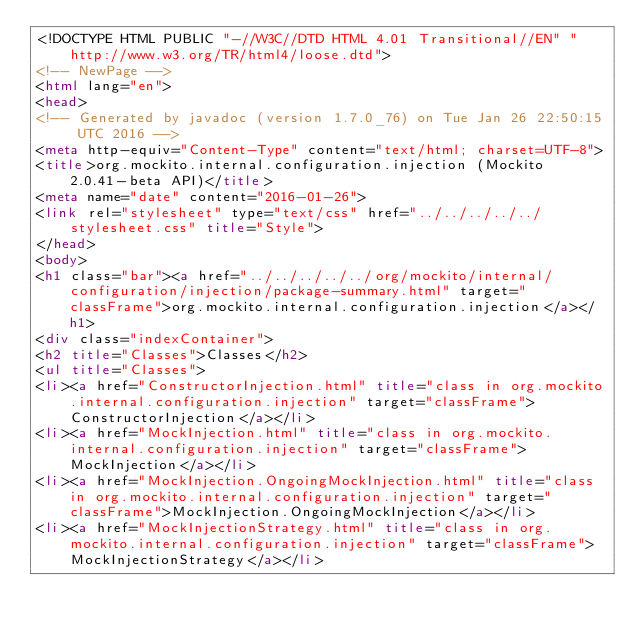<code> <loc_0><loc_0><loc_500><loc_500><_HTML_><!DOCTYPE HTML PUBLIC "-//W3C//DTD HTML 4.01 Transitional//EN" "http://www.w3.org/TR/html4/loose.dtd">
<!-- NewPage -->
<html lang="en">
<head>
<!-- Generated by javadoc (version 1.7.0_76) on Tue Jan 26 22:50:15 UTC 2016 -->
<meta http-equiv="Content-Type" content="text/html; charset=UTF-8">
<title>org.mockito.internal.configuration.injection (Mockito 2.0.41-beta API)</title>
<meta name="date" content="2016-01-26">
<link rel="stylesheet" type="text/css" href="../../../../../stylesheet.css" title="Style">
</head>
<body>
<h1 class="bar"><a href="../../../../../org/mockito/internal/configuration/injection/package-summary.html" target="classFrame">org.mockito.internal.configuration.injection</a></h1>
<div class="indexContainer">
<h2 title="Classes">Classes</h2>
<ul title="Classes">
<li><a href="ConstructorInjection.html" title="class in org.mockito.internal.configuration.injection" target="classFrame">ConstructorInjection</a></li>
<li><a href="MockInjection.html" title="class in org.mockito.internal.configuration.injection" target="classFrame">MockInjection</a></li>
<li><a href="MockInjection.OngoingMockInjection.html" title="class in org.mockito.internal.configuration.injection" target="classFrame">MockInjection.OngoingMockInjection</a></li>
<li><a href="MockInjectionStrategy.html" title="class in org.mockito.internal.configuration.injection" target="classFrame">MockInjectionStrategy</a></li></code> 